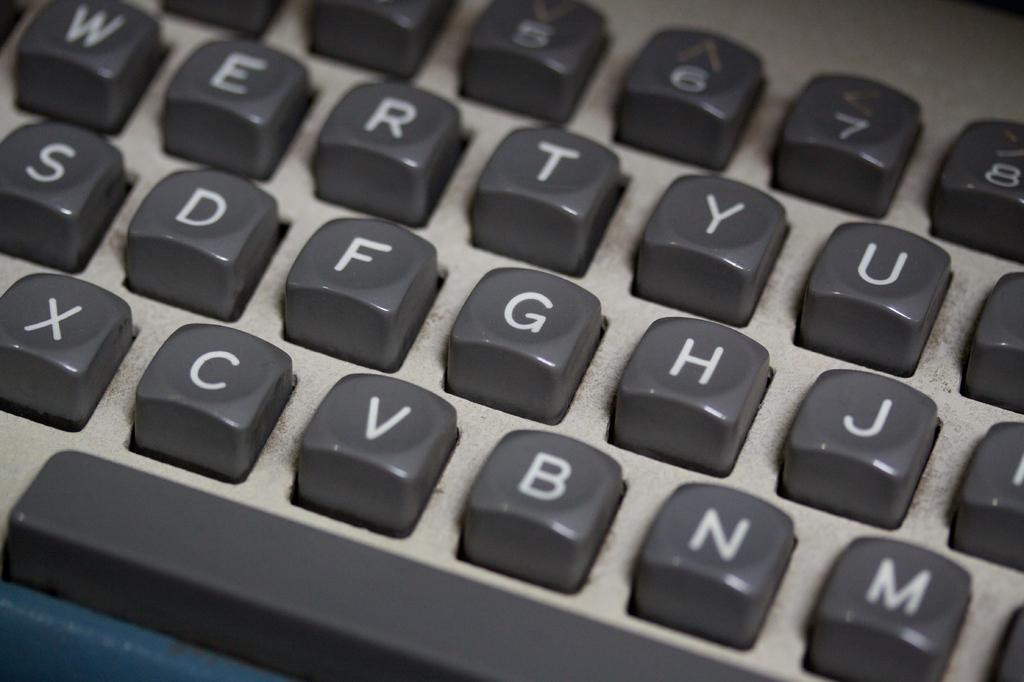<image>
Present a compact description of the photo's key features. A keyboard shows the letters W, E and R in a row. 